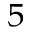<formula> <loc_0><loc_0><loc_500><loc_500>^ { 5 }</formula> 